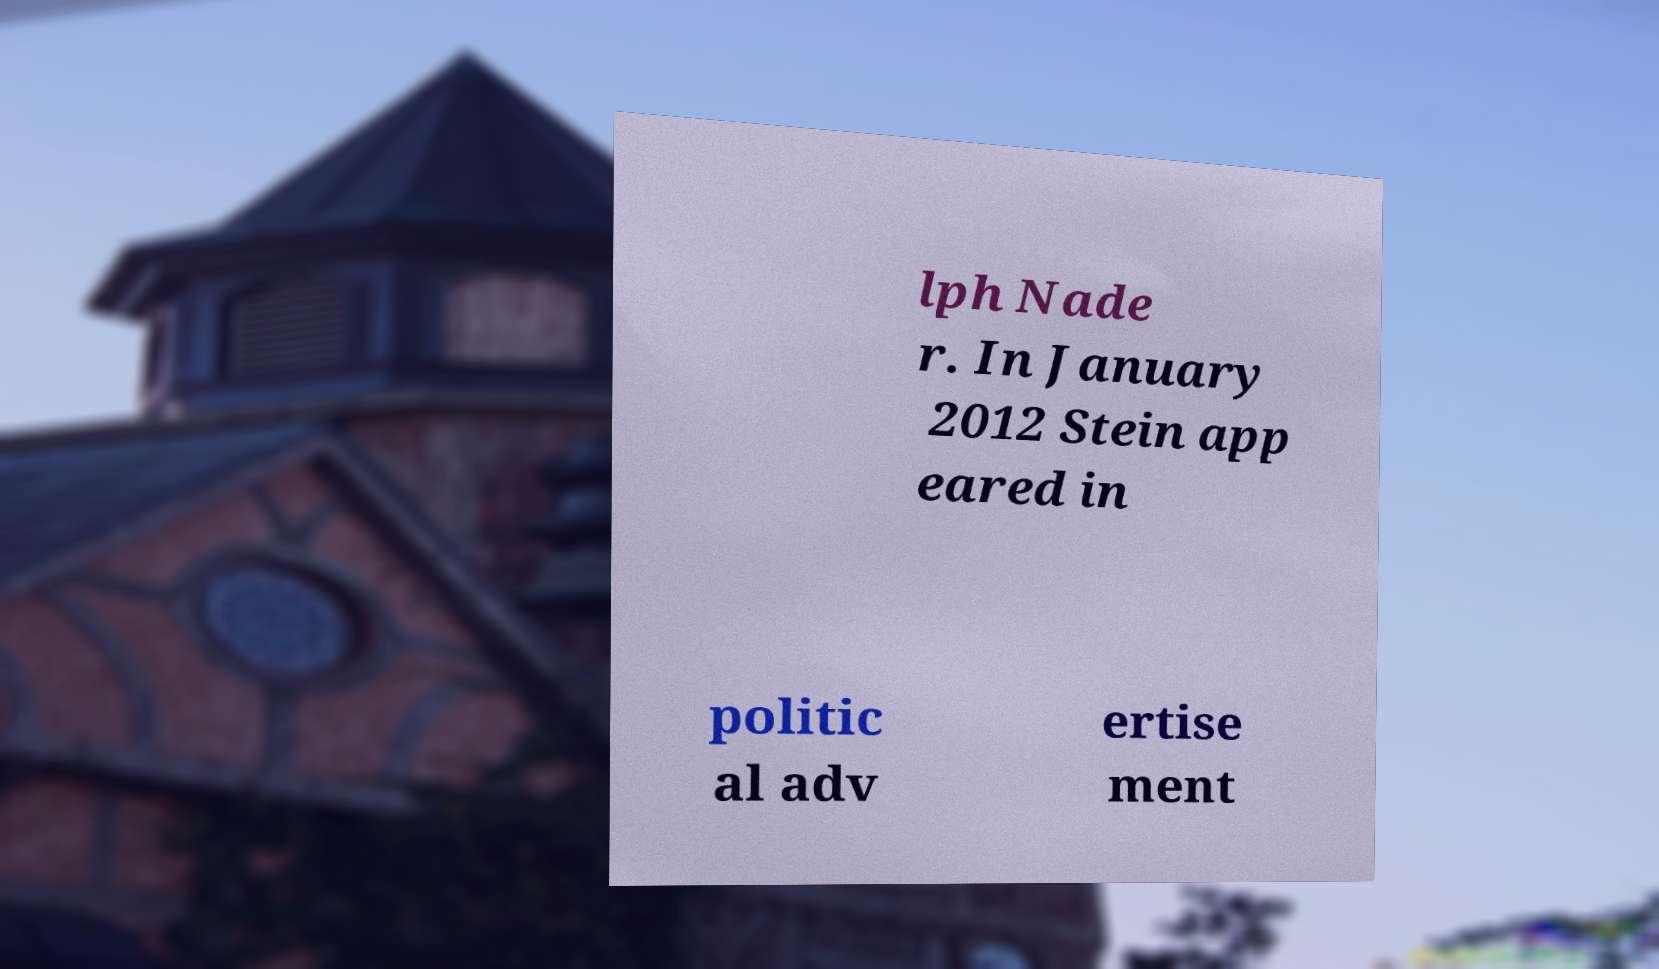Please read and relay the text visible in this image. What does it say? lph Nade r. In January 2012 Stein app eared in politic al adv ertise ment 